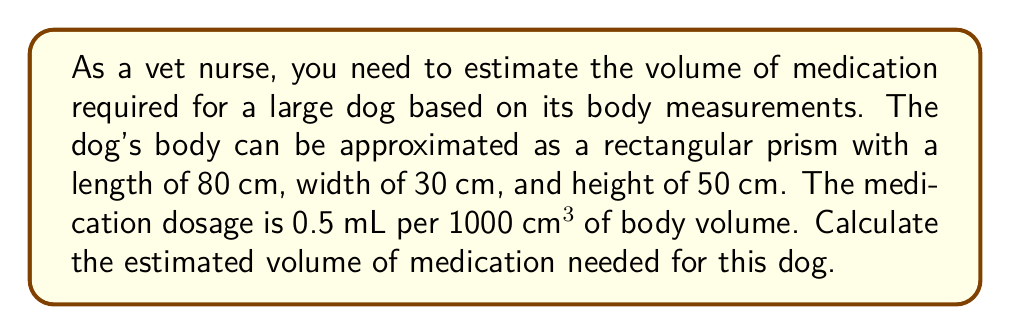Can you solve this math problem? To solve this problem, we'll follow these steps:

1. Calculate the volume of the dog's body using the rectangular prism formula:
   $$V = l \times w \times h$$
   where $V$ is volume, $l$ is length, $w$ is width, and $h$ is height.

2. Substitute the given measurements:
   $$V = 80 \text{ cm} \times 30 \text{ cm} \times 50 \text{ cm}$$

3. Calculate the volume:
   $$V = 120,000 \text{ cm}^3$$

4. Set up the proportion for the medication dosage:
   $$\frac{0.5 \text{ mL}}{1000 \text{ cm}^3} = \frac{x \text{ mL}}{120,000 \text{ cm}^3}$$

5. Cross multiply:
   $$0.5 \times 120,000 = 1000x$$

6. Solve for $x$:
   $$x = \frac{0.5 \times 120,000}{1000} = 60 \text{ mL}$$

Therefore, the estimated volume of medication needed for this dog is 60 mL.
Answer: 60 mL 